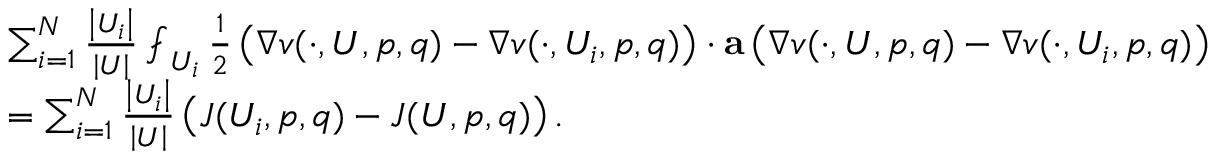<formula> <loc_0><loc_0><loc_500><loc_500>\begin{array} { r l } & { \sum _ { i = 1 } ^ { N } \frac { \left | U _ { i } \right | } { \left | U \right | } \ f i n t _ { U _ { i } } \frac { 1 } { 2 } \left ( \nabla v ( \cdot , U , p , q ) - \nabla v ( \cdot , U _ { i } , p , q ) \right ) \cdot a \left ( \nabla v ( \cdot , U , p , q ) - \nabla v ( \cdot , U _ { i } , p , q ) \right ) } \\ & { = \sum _ { i = 1 } ^ { N } \frac { \left | U _ { i } \right | } { \left | U \right | } \left ( J ( U _ { i } , p , q ) - J ( U , p , q ) \right ) . } \end{array}</formula> 